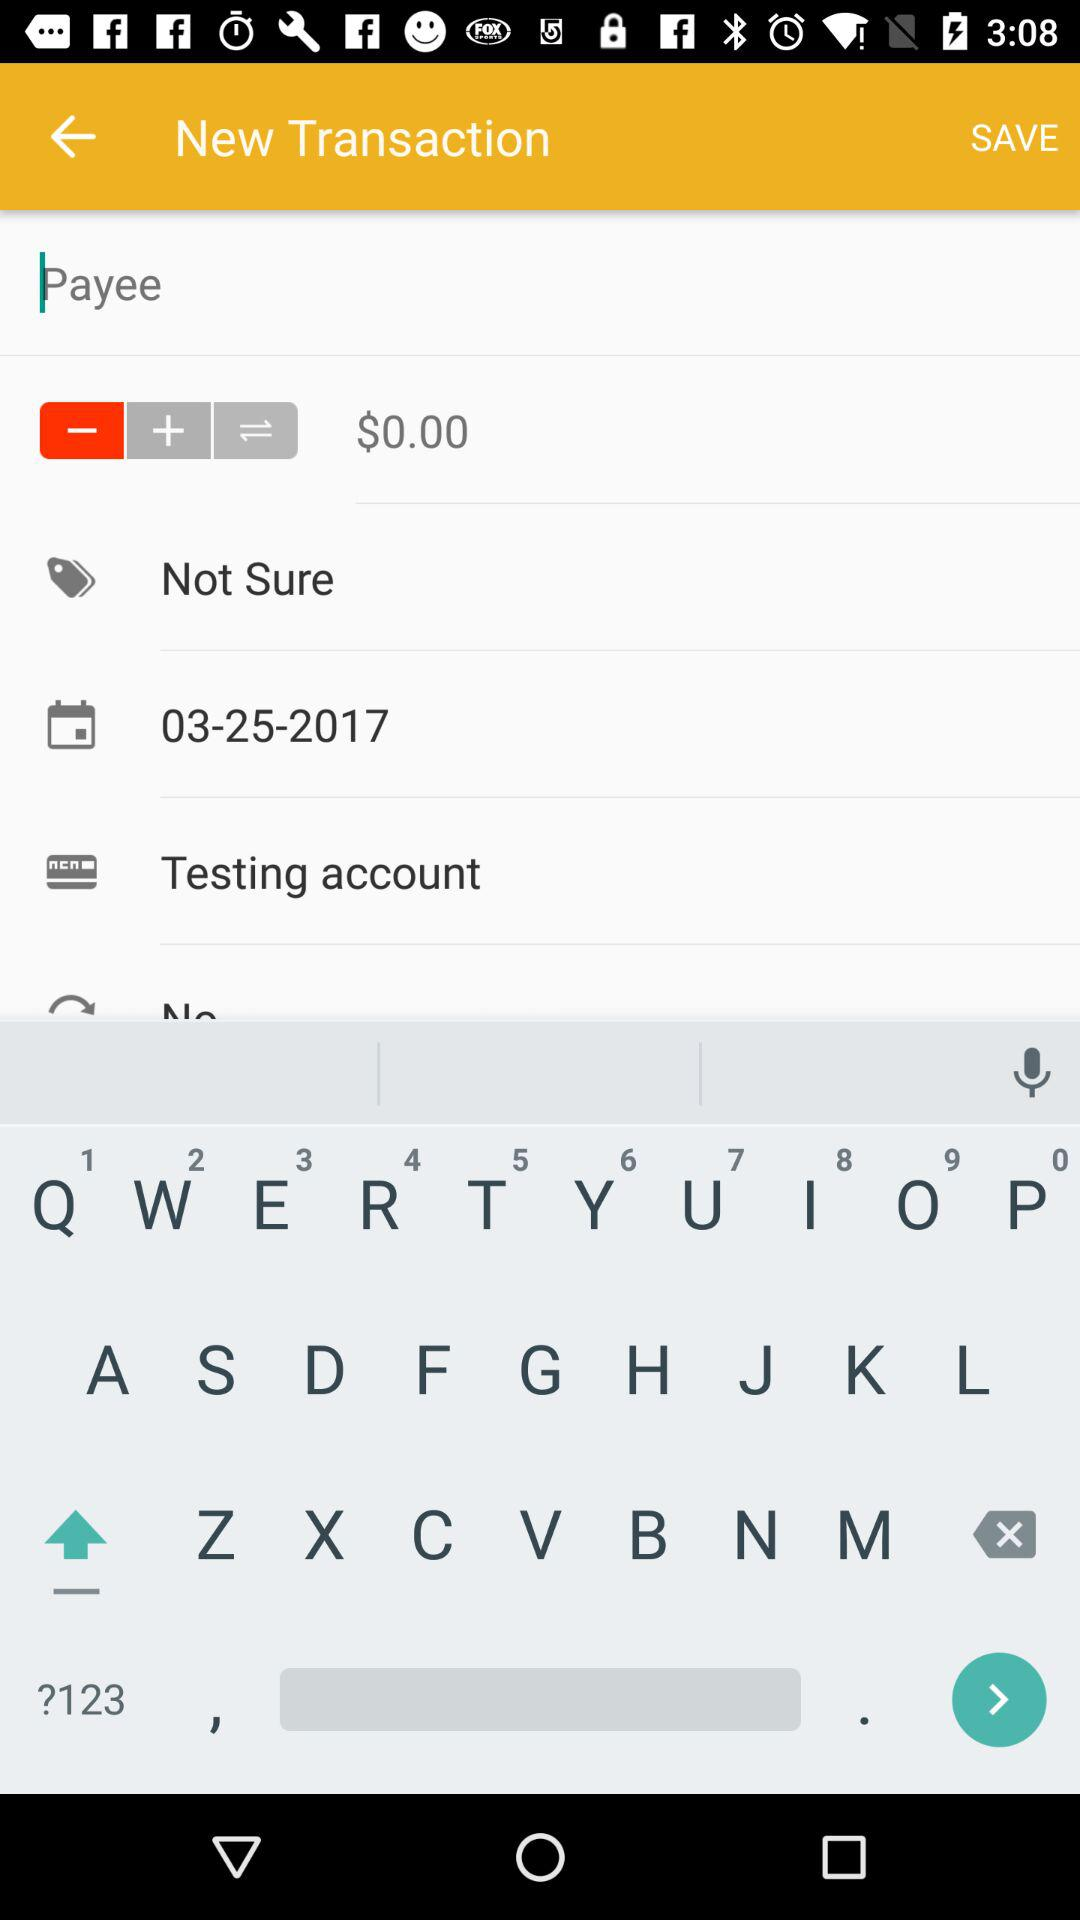How much is the total amount of the transaction?
Answer the question using a single word or phrase. $0.00 